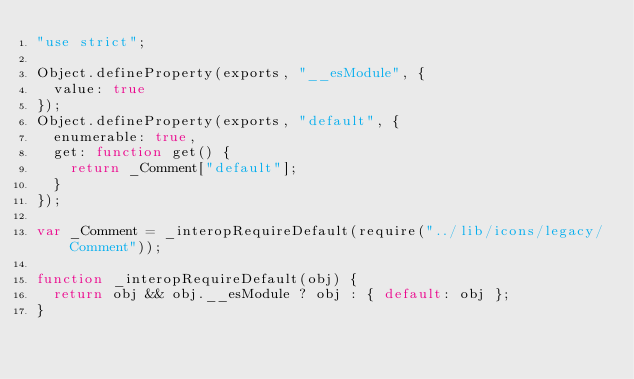Convert code to text. <code><loc_0><loc_0><loc_500><loc_500><_JavaScript_>"use strict";

Object.defineProperty(exports, "__esModule", {
  value: true
});
Object.defineProperty(exports, "default", {
  enumerable: true,
  get: function get() {
    return _Comment["default"];
  }
});

var _Comment = _interopRequireDefault(require("../lib/icons/legacy/Comment"));

function _interopRequireDefault(obj) {
  return obj && obj.__esModule ? obj : { default: obj };
}
</code> 